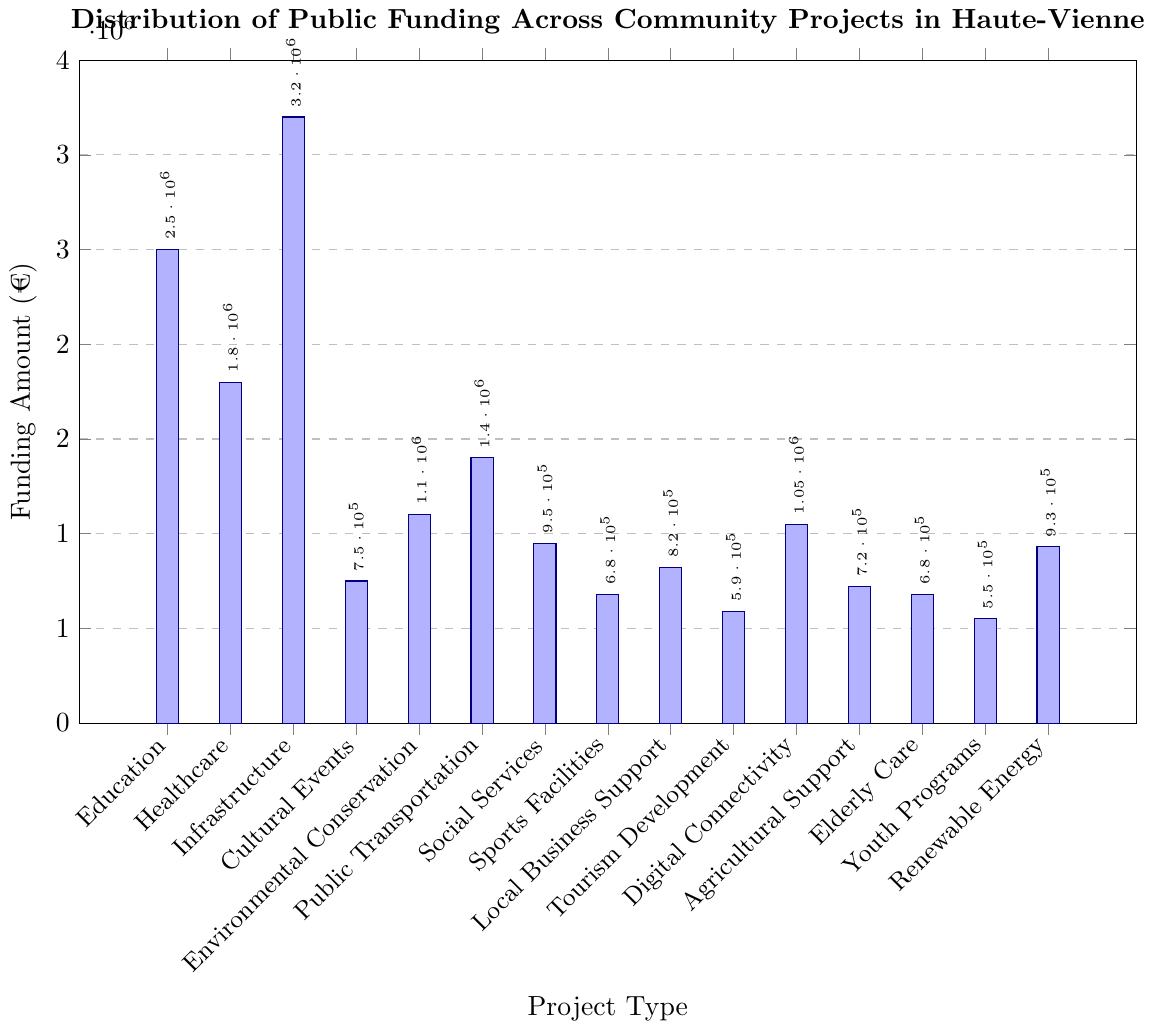Which project type received the highest amount of public funding? The bar for Infrastructure is the tallest, indicating it received the highest funding.
Answer: Infrastructure Which project types received less than €1,000,000 in public funding? Bars representing funding amounts less than one tick below €1,000,000 are Cultural Events, Social Services, Sports Facilities, Local Business Support, Tourism Development, Agricultural Support, Elderly Care, and Youth Programs.
Answer: Cultural Events, Social Services, Sports Facilities, Local Business Support, Tourism Development, Agricultural Support, Elderly Care, Youth Programs How much more funding did Infrastructure receive compared to Healthcare? Infrastructure received €3,200,000 and Healthcare received €1,800,000. Subtract the two to find the difference: €3,200,000 - €1,800,000 = €1,400,000.
Answer: €1,400,000 Is the funding amount for Digital Connectivity greater than that for Sports Facilities and Youth Programs combined? Digital Connectivity received €1,050,000. Sports Facilities and Youth Programs combined is €680,000 + €550,000 = €1,230,000. Since €1,050,000 < €1,230,000, the funding for Digital Connectivity is not greater.
Answer: No What is the sum of the funding amounts for Environmental Conservation and Renewable Energy projects? Environmental Conservation received €1,100,000 and Renewable Energy received €930,000. The sum is €1,100,000 + €930,000 = €2,030,000.
Answer: €2,030,000 Which project type received closest to €900,000 in public funding? Renewable Energy received €930,000 which is closest to €900,000 compared to the other amounts listed.
Answer: Renewable Energy By how much does the funding for Education exceed the combined total for Tourism Development and Youth Programs? Education received €2,500,000, while Tourism Development and Youth Programs together received €590,000 + €550,000 = €1,140,000. The difference is €2,500,000 - €1,140,000 = €1,360,000.
Answer: €1,360,000 Rank the top three project types by the amount of public funding received. Observing the heights of the bars, they are: 1) Infrastructure (€3,200,000), 2) Education (€2,500,000), 3) Healthcare (€1,800,000).
Answer: 1) Infrastructure, 2) Education, 3) Healthcare What is the median funding amount among all project types? List the funding amounts in ascending order: €550,000, €590,000, €680,000, €680,000, €720,000, €750,000, €820,000, €930,000, €950,000, €1,050,000, €1,100,000, €1,400,000, €1,800,000, €2,500,000, €3,200,000. The median is the middle value in the ordered list, which is the 8th value: €950,000.
Answer: €950,000 